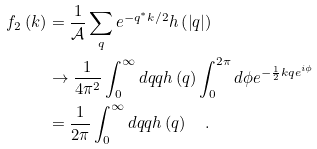Convert formula to latex. <formula><loc_0><loc_0><loc_500><loc_500>f _ { 2 } \left ( k \right ) & = \frac { 1 } { \mathcal { A } } \sum _ { q } e ^ { - q ^ { \ast } k / 2 } h \left ( \left | q \right | \right ) \\ & \rightarrow \frac { 1 } { 4 \pi ^ { 2 } } \int _ { 0 } ^ { \infty } d q q h \left ( q \right ) \int _ { 0 } ^ { 2 \pi } d \phi e ^ { - \frac { 1 } { 2 } k q e ^ { i \phi } } \\ & = \frac { 1 } { 2 \pi } \int _ { 0 } ^ { \infty } d q q h \left ( q \right ) \quad .</formula> 